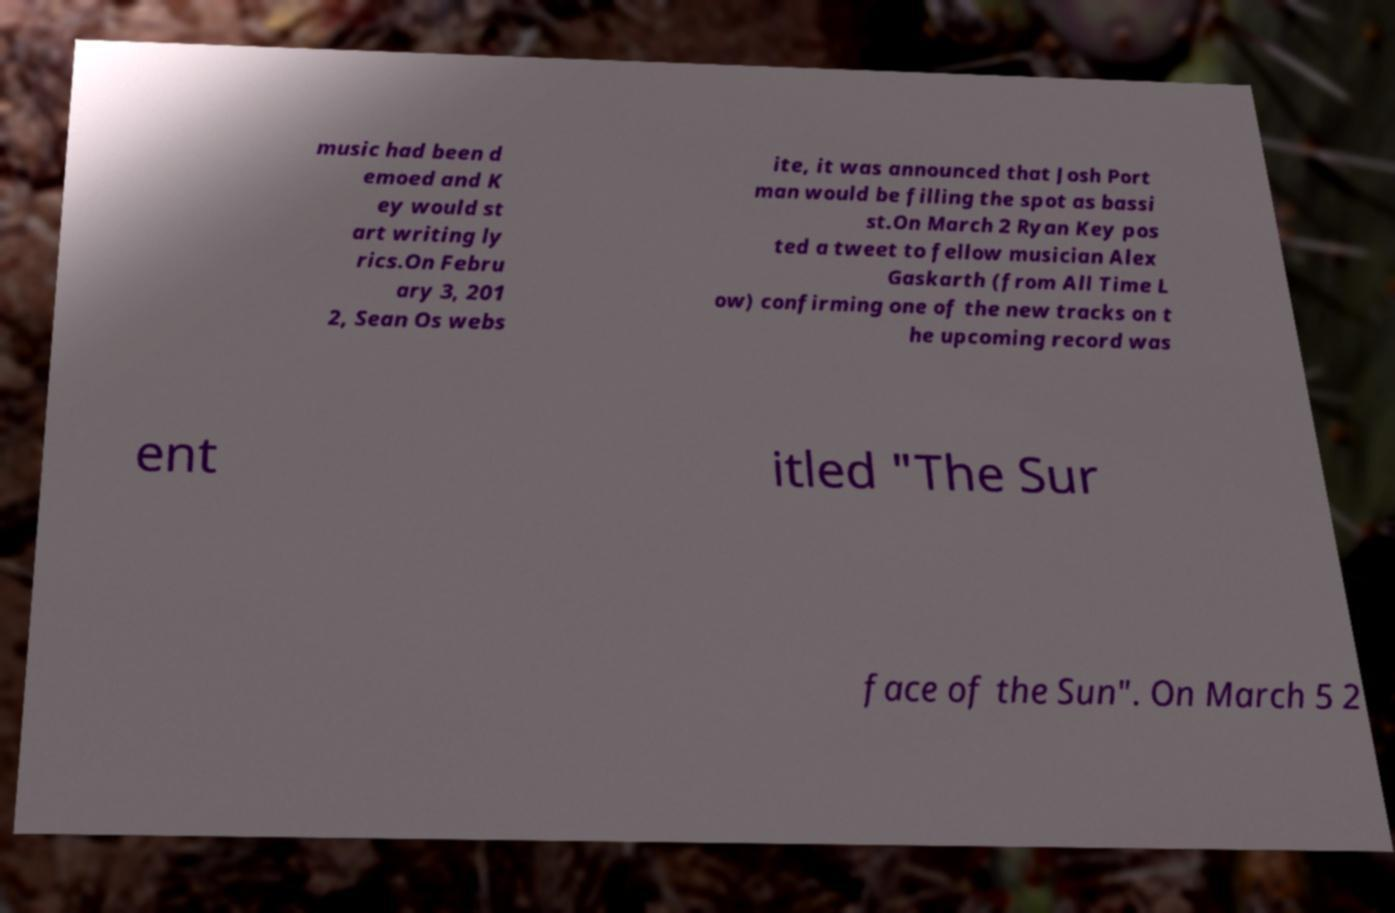There's text embedded in this image that I need extracted. Can you transcribe it verbatim? music had been d emoed and K ey would st art writing ly rics.On Febru ary 3, 201 2, Sean Os webs ite, it was announced that Josh Port man would be filling the spot as bassi st.On March 2 Ryan Key pos ted a tweet to fellow musician Alex Gaskarth (from All Time L ow) confirming one of the new tracks on t he upcoming record was ent itled "The Sur face of the Sun". On March 5 2 